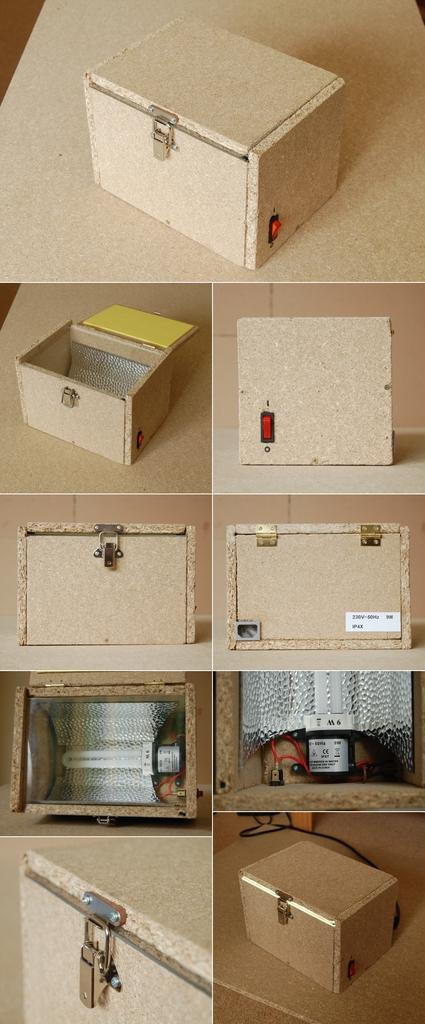What type of picture is in the image? There is a collage picture in the image. What color is the box in the image? The box in the image is cream color. What can be seen providing illumination in the image? There are lights visible in the image. What type of window treatment is present in the image? There is a curtain in cream color in the image. How many dolls are sitting on the curtain in the image? There are no dolls present in the image; it features a collage picture, a cream-colored box, lights, and a cream-colored curtain. 